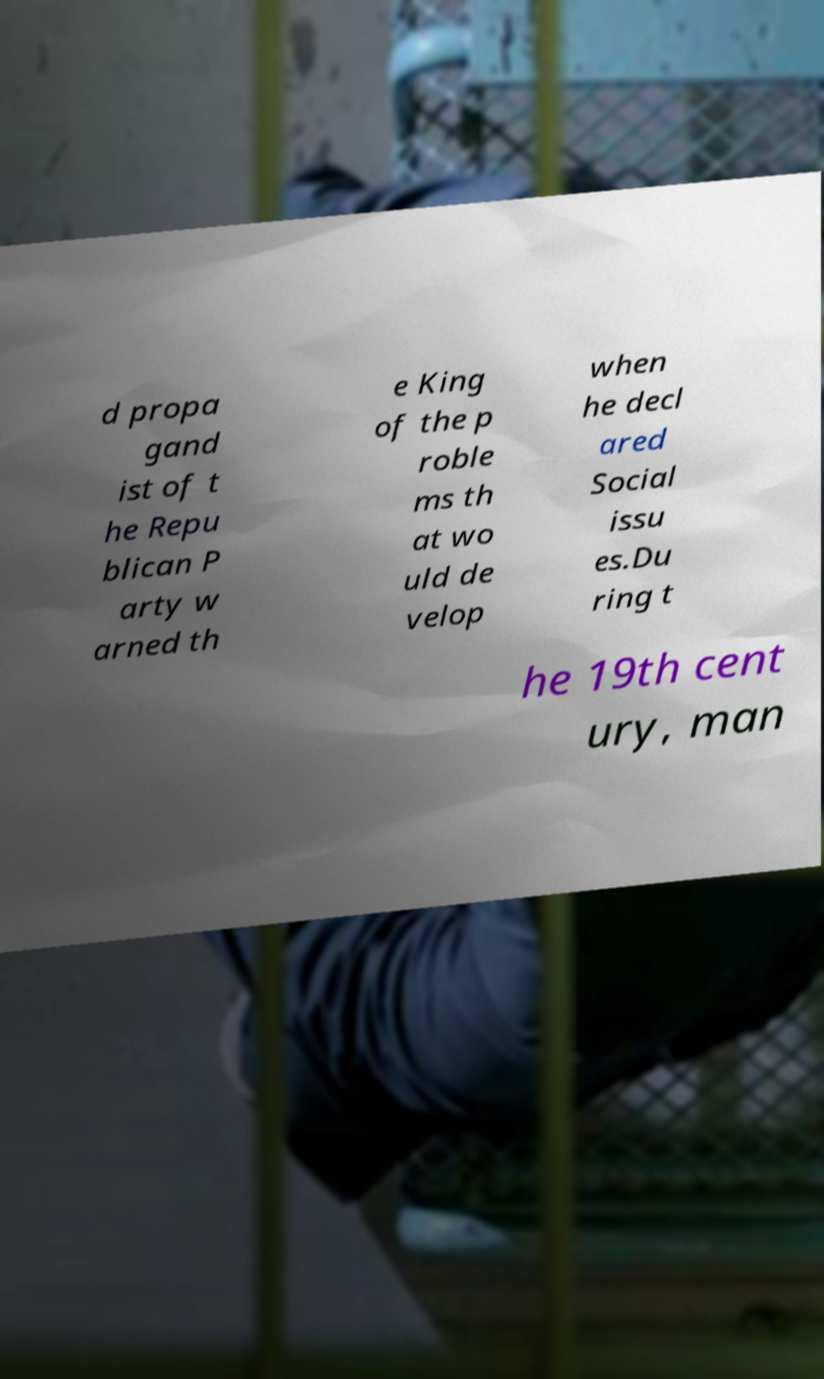Please read and relay the text visible in this image. What does it say? d propa gand ist of t he Repu blican P arty w arned th e King of the p roble ms th at wo uld de velop when he decl ared Social issu es.Du ring t he 19th cent ury, man 